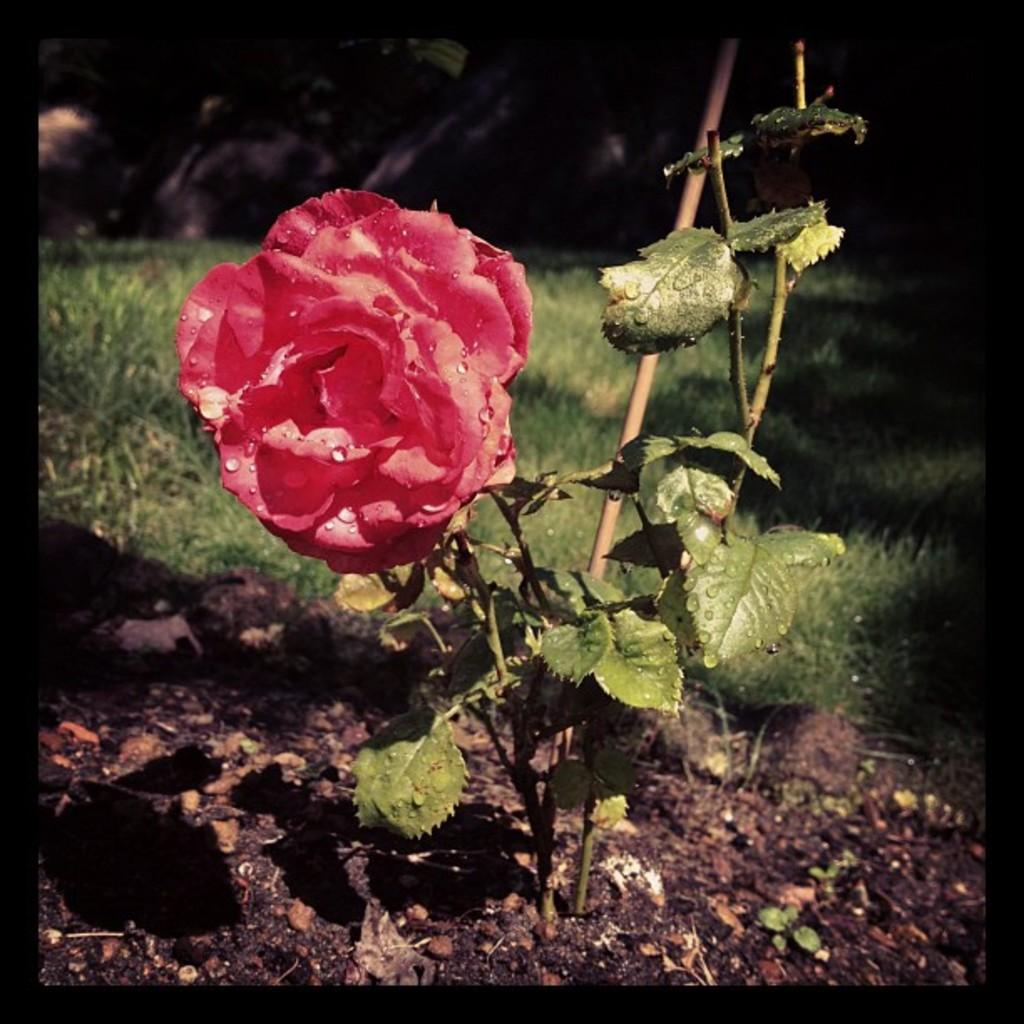What type of plant is visible in the image? There is a rose plant in the image. What part of the rose plant is in bloom? There is a rose flower in the image. What type of vegetation is present in the image besides the rose plant? There is grass in the image. What is the color of the background in the image? The background of the image is dark. Can you see any snails requesting oil in the image? There are no snails or any request for oil present in the image. 